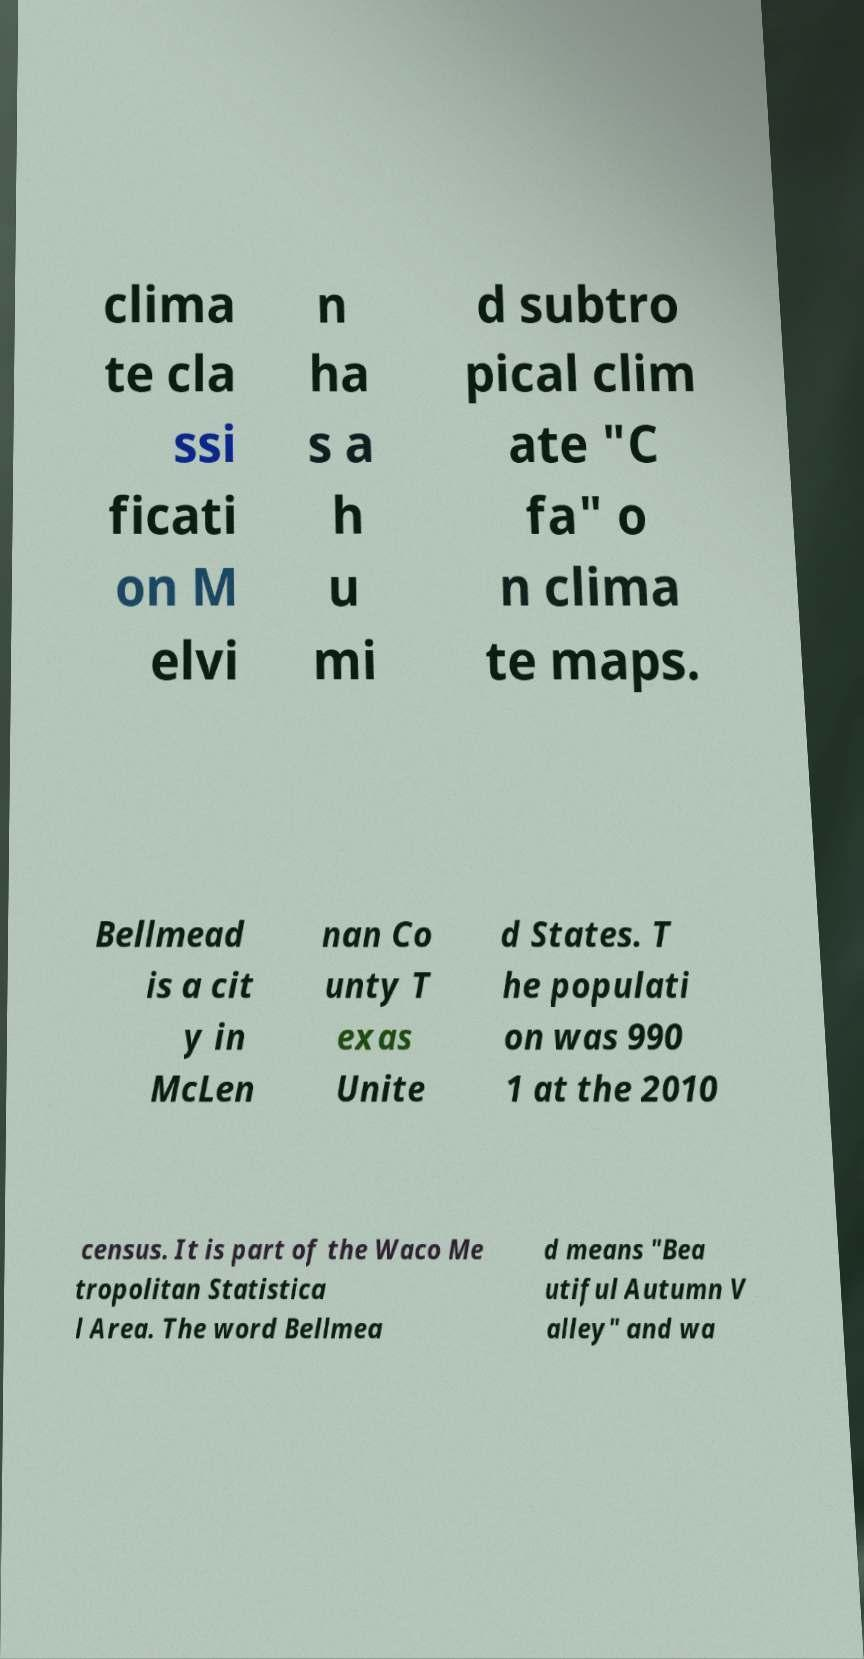For documentation purposes, I need the text within this image transcribed. Could you provide that? clima te cla ssi ficati on M elvi n ha s a h u mi d subtro pical clim ate "C fa" o n clima te maps. Bellmead is a cit y in McLen nan Co unty T exas Unite d States. T he populati on was 990 1 at the 2010 census. It is part of the Waco Me tropolitan Statistica l Area. The word Bellmea d means "Bea utiful Autumn V alley" and wa 